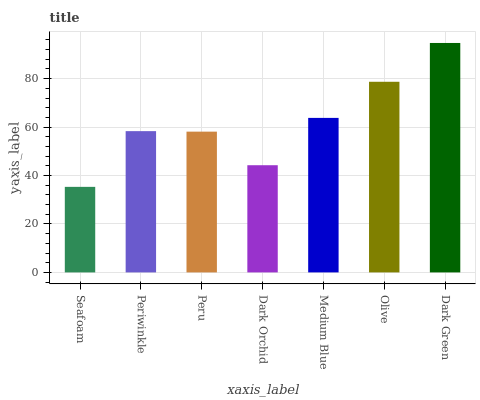Is Seafoam the minimum?
Answer yes or no. Yes. Is Dark Green the maximum?
Answer yes or no. Yes. Is Periwinkle the minimum?
Answer yes or no. No. Is Periwinkle the maximum?
Answer yes or no. No. Is Periwinkle greater than Seafoam?
Answer yes or no. Yes. Is Seafoam less than Periwinkle?
Answer yes or no. Yes. Is Seafoam greater than Periwinkle?
Answer yes or no. No. Is Periwinkle less than Seafoam?
Answer yes or no. No. Is Periwinkle the high median?
Answer yes or no. Yes. Is Periwinkle the low median?
Answer yes or no. Yes. Is Olive the high median?
Answer yes or no. No. Is Dark Green the low median?
Answer yes or no. No. 